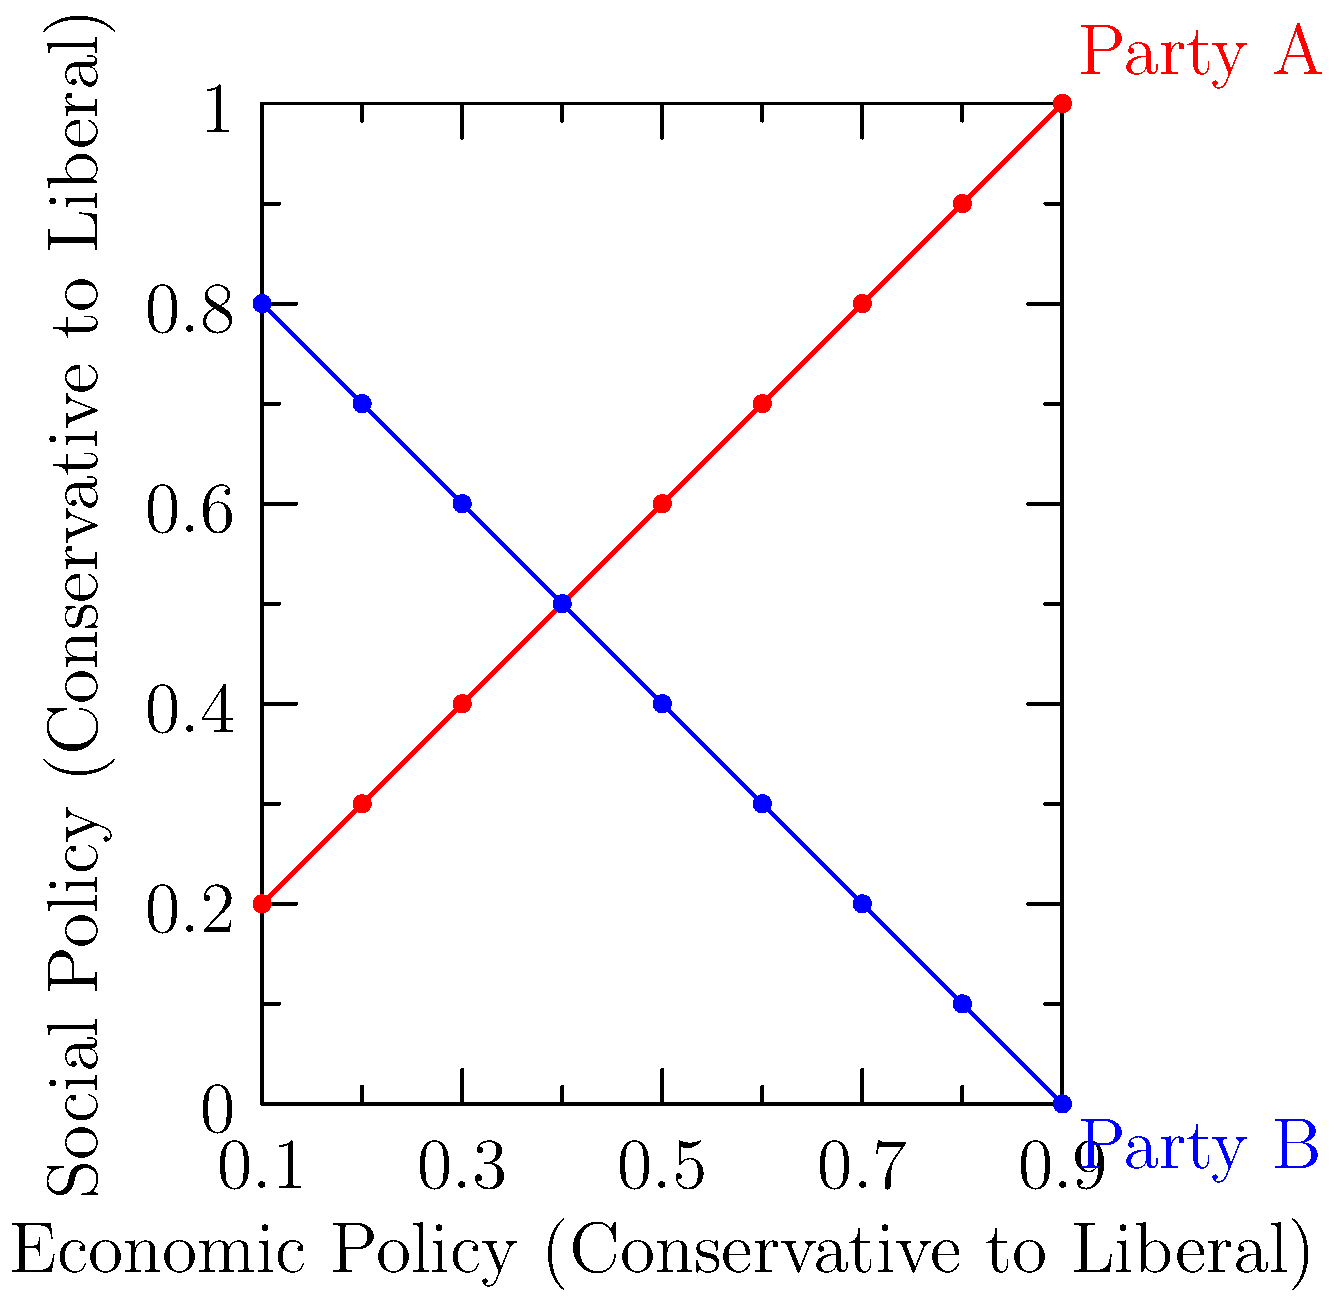Based on the scatter plot of voting patterns, which party is more likely to support progressive social policies while maintaining a relatively conservative economic stance? To answer this question, we need to analyze the voting patterns represented in the scatter plot:

1. The x-axis represents economic policy, ranging from conservative (left) to liberal (right).
2. The y-axis represents social policy, ranging from conservative (bottom) to liberal (top).
3. There are two distinct patterns represented by red dots (Party A) and blue dots (Party B).

Let's examine each party's pattern:

4. Party A (red):
   - Economic policy: Ranges from conservative to moderately liberal
   - Social policy: Strongly correlates with more liberal positions as economic policy becomes more liberal

5. Party B (blue):
   - Economic policy: Also ranges from conservative to moderately liberal
   - Social policy: Inversely correlates with economic policy, becoming more conservative as economic policy becomes more liberal

6. Comparing the two:
   - Party A shows a consistent trend towards more liberal social policies across the economic spectrum
   - Party B shows a trend towards more conservative social policies, especially as economic policies become more liberal

7. The question asks for a party that supports progressive social policies while maintaining a relatively conservative economic stance.

8. Looking at the left side of the graph (more conservative economic policies):
   - Party A still maintains higher positions on the social policy axis compared to Party B

Therefore, Party A is more likely to support progressive social policies while maintaining a relatively conservative economic stance.
Answer: Party A 